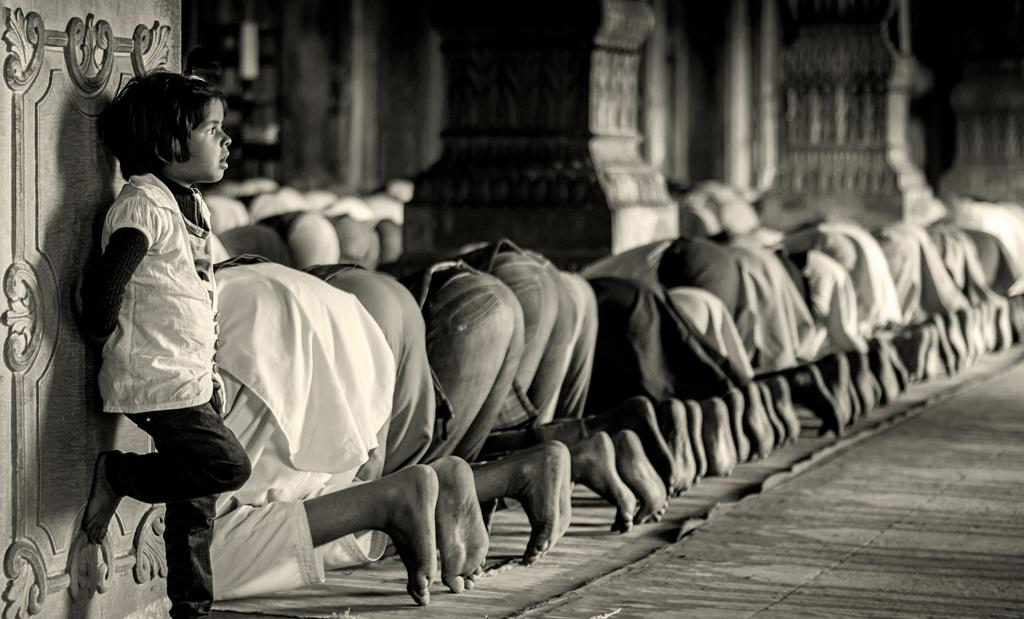What is the color scheme of the image? The image is black and white. What are the people in the image doing? People are praying in the image. What can be seen in the background of the image? There are pillars in the background of the image. Where is the kid located in the image? There is a kid standing near a pillar on the left side of the image. What type of destruction can be seen in the image? There is no destruction present in the image; it features people praying and pillars in the background. Can you tell me which actor is performing in the image? There are no actors or performances depicted in the image; it shows people praying. 